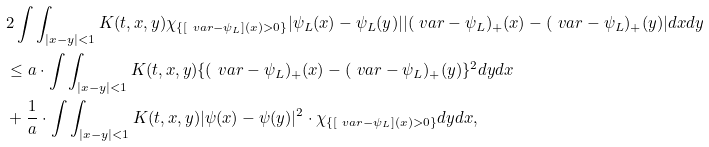Convert formula to latex. <formula><loc_0><loc_0><loc_500><loc_500>& 2 \int \int _ { | x - y | < 1 } K ( t , x , y ) \chi _ { \{ [ \ v a r - \psi _ { L } ] ( x ) > 0 \} } | \psi _ { L } ( x ) - \psi _ { L } ( y ) | | ( \ v a r - \psi _ { L } ) _ { + } ( x ) - ( \ v a r - \psi _ { L } ) _ { + } ( y ) | d x d y \\ & \leq a \cdot \int \int _ { | x - y | < 1 } K ( t , x , y ) \{ ( \ v a r - \psi _ { L } ) _ { + } ( x ) - ( \ v a r - \psi _ { L } ) _ { + } ( y ) \} ^ { 2 } d y d x \\ & + \frac { 1 } { a } \cdot \int \int _ { | x - y | < 1 } K ( t , x , y ) | \psi ( x ) - \psi ( y ) | ^ { 2 } \cdot \chi _ { \{ [ \ v a r - \psi _ { L } ] ( x ) > 0 \} } d y d x ,</formula> 